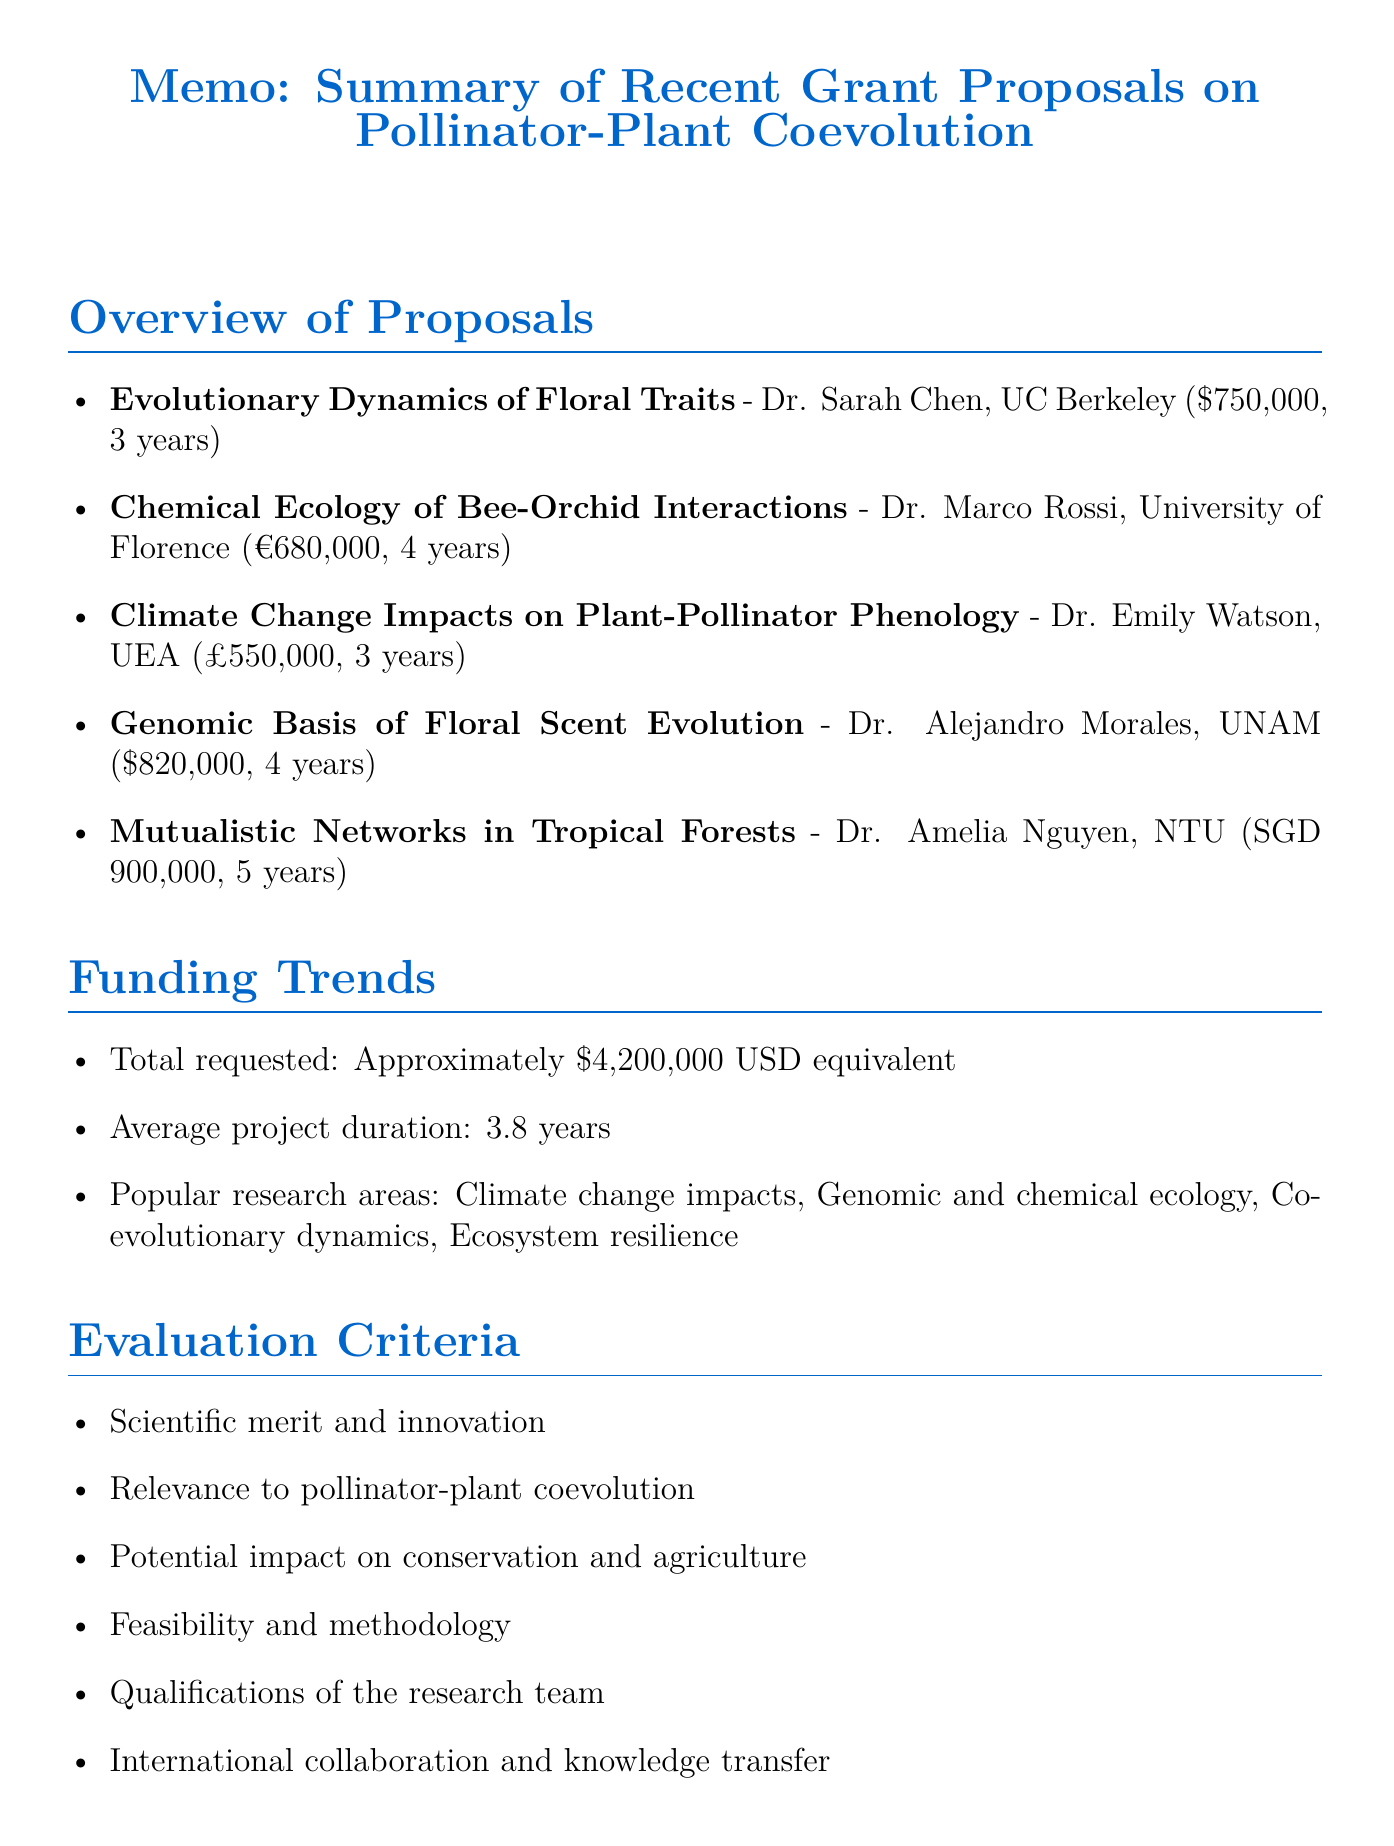What is the title of Dr. Sarah Chen's proposal? The title is the first piece of information provided for Dr. Sarah Chen's proposal, which is "Evolutionary Dynamics of Floral Traits in Response to Hummingbird Pollination."
Answer: Evolutionary Dynamics of Floral Traits in Response to Hummingbird Pollination How much funding is requested by Dr. Marco Rossi? The funding requested by Dr. Marco Rossi is listed directly in the document as "€680,000."
Answer: €680,000 What is the average duration of the projects? The average duration is clearly stated in the funding trends section as "3.8 years."
Answer: 3.8 years Which research area is highlighted as increasingly popular among the proposals? The popular research areas include many themes, but "Climate change impacts" is specifically listed as one of them.
Answer: Climate change impacts What is the main focus of Dr. Emily Watson's proposal? The main focus is about examining how climate change affects the timing of flowering and pollinator emergence.
Answer: Climate change impacts on timing of flowering and pollinator emergence How many years will Dr. Alejandro Morales's research project last? The duration of Dr. Alejandro Morales's project is directly stated as "4 years."
Answer: 4 years Which emerging theme emphasizes the use of a particular analytical approach? The theme "Increasing use of network analysis in community ecology" highlights a specific analytical approach being employed.
Answer: Increasing use of network analysis in community ecology What evaluation criterion assesses the qualifications of the research team? The evaluation criterion is listed as "Qualifications of the research team," which directly addresses this aspect.
Answer: Qualifications of the research team Who is the principal investigator for the proposal on mutualistic networks? The principal investigator is identified as Dr. Amelia Nguyen, which is directly stated under her project summary.
Answer: Dr. Amelia Nguyen 